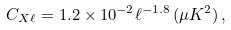<formula> <loc_0><loc_0><loc_500><loc_500>C _ { X \ell } = 1 . 2 \times 1 0 ^ { - 2 } \ell ^ { - 1 . 8 } \, ( \mu K ^ { 2 } ) \, ,</formula> 